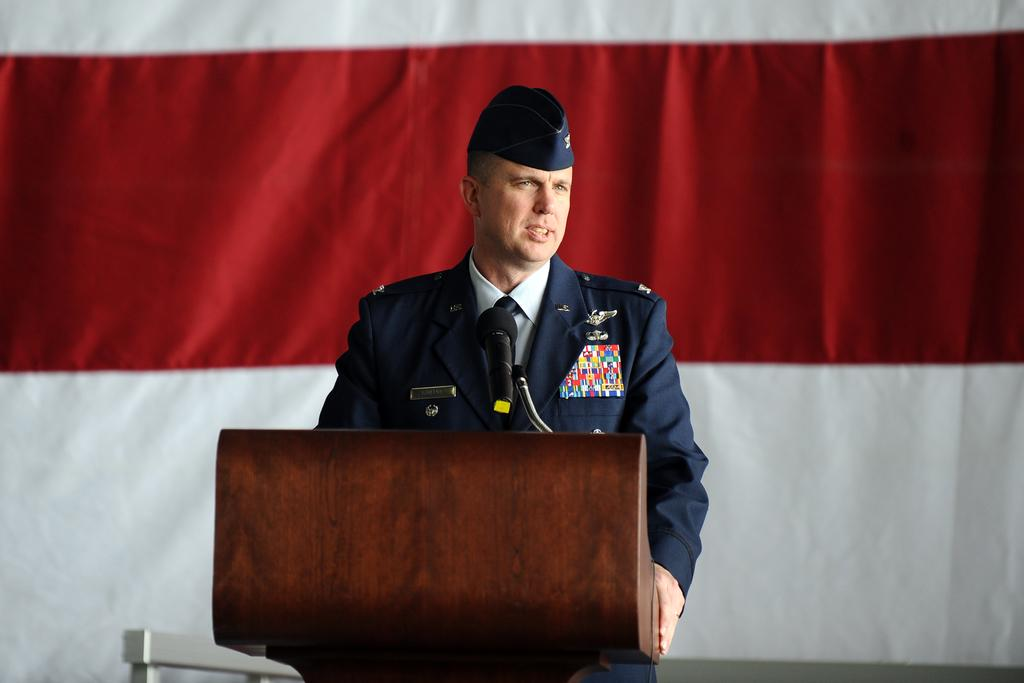What is the main object in the middle of the image? There is a podium with a mic in the middle of the image. Who is standing behind the podium? There is a man standing behind the podium. What is the man wearing on his head? The man is wearing a hat. What can be seen behind the man? There is a red and white background behind the man. Can you see a river flowing behind the man in the image? No, there is no river visible in the image. The background behind the man is red and white. 